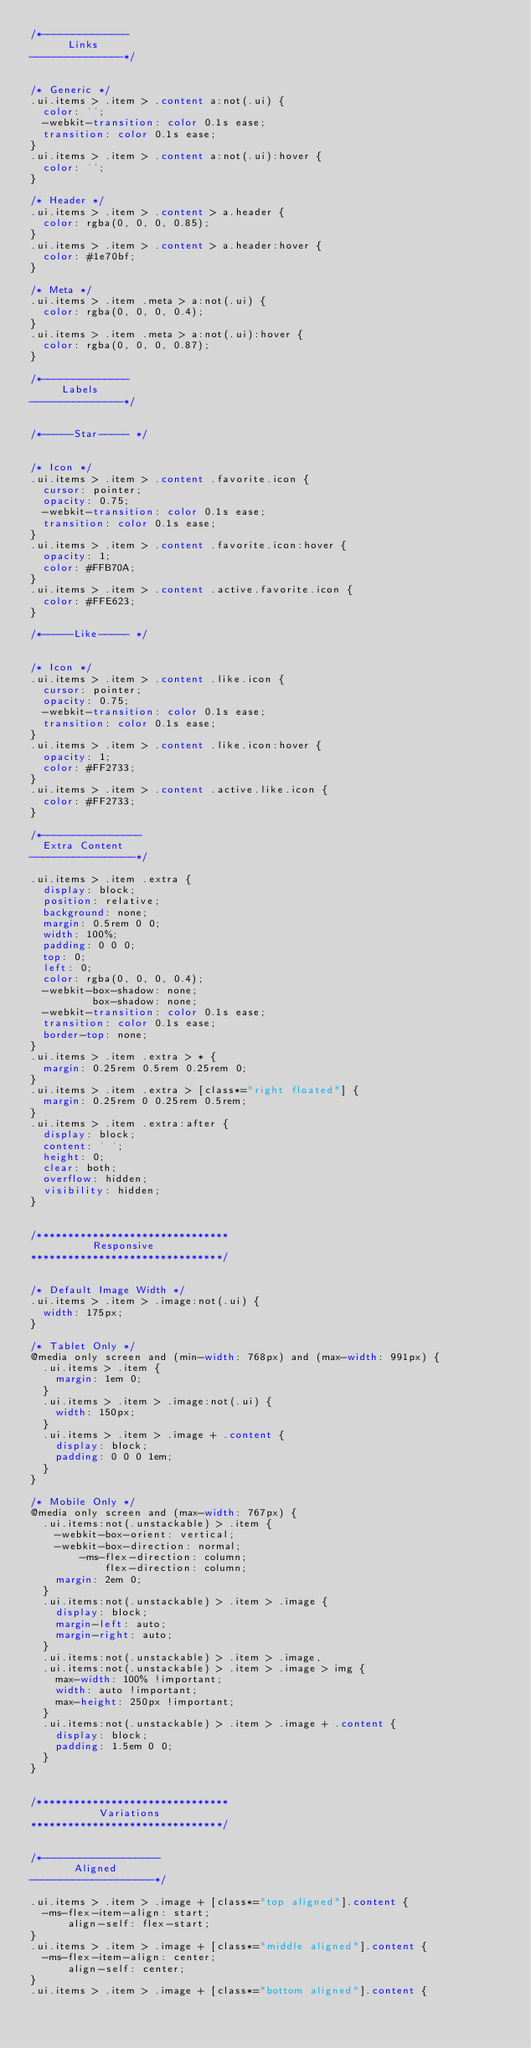Convert code to text. <code><loc_0><loc_0><loc_500><loc_500><_CSS_>/*--------------
      Links
---------------*/


/* Generic */
.ui.items > .item > .content a:not(.ui) {
  color: '';
  -webkit-transition: color 0.1s ease;
  transition: color 0.1s ease;
}
.ui.items > .item > .content a:not(.ui):hover {
  color: '';
}

/* Header */
.ui.items > .item > .content > a.header {
  color: rgba(0, 0, 0, 0.85);
}
.ui.items > .item > .content > a.header:hover {
  color: #1e70bf;
}

/* Meta */
.ui.items > .item .meta > a:not(.ui) {
  color: rgba(0, 0, 0, 0.4);
}
.ui.items > .item .meta > a:not(.ui):hover {
  color: rgba(0, 0, 0, 0.87);
}

/*--------------
     Labels
---------------*/


/*-----Star----- */


/* Icon */
.ui.items > .item > .content .favorite.icon {
  cursor: pointer;
  opacity: 0.75;
  -webkit-transition: color 0.1s ease;
  transition: color 0.1s ease;
}
.ui.items > .item > .content .favorite.icon:hover {
  opacity: 1;
  color: #FFB70A;
}
.ui.items > .item > .content .active.favorite.icon {
  color: #FFE623;
}

/*-----Like----- */


/* Icon */
.ui.items > .item > .content .like.icon {
  cursor: pointer;
  opacity: 0.75;
  -webkit-transition: color 0.1s ease;
  transition: color 0.1s ease;
}
.ui.items > .item > .content .like.icon:hover {
  opacity: 1;
  color: #FF2733;
}
.ui.items > .item > .content .active.like.icon {
  color: #FF2733;
}

/*----------------
  Extra Content
-----------------*/

.ui.items > .item .extra {
  display: block;
  position: relative;
  background: none;
  margin: 0.5rem 0 0;
  width: 100%;
  padding: 0 0 0;
  top: 0;
  left: 0;
  color: rgba(0, 0, 0, 0.4);
  -webkit-box-shadow: none;
          box-shadow: none;
  -webkit-transition: color 0.1s ease;
  transition: color 0.1s ease;
  border-top: none;
}
.ui.items > .item .extra > * {
  margin: 0.25rem 0.5rem 0.25rem 0;
}
.ui.items > .item .extra > [class*="right floated"] {
  margin: 0.25rem 0 0.25rem 0.5rem;
}
.ui.items > .item .extra:after {
  display: block;
  content: ' ';
  height: 0;
  clear: both;
  overflow: hidden;
  visibility: hidden;
}


/*******************************
          Responsive
*******************************/


/* Default Image Width */
.ui.items > .item > .image:not(.ui) {
  width: 175px;
}

/* Tablet Only */
@media only screen and (min-width: 768px) and (max-width: 991px) {
  .ui.items > .item {
    margin: 1em 0;
  }
  .ui.items > .item > .image:not(.ui) {
    width: 150px;
  }
  .ui.items > .item > .image + .content {
    display: block;
    padding: 0 0 0 1em;
  }
}

/* Mobile Only */
@media only screen and (max-width: 767px) {
  .ui.items:not(.unstackable) > .item {
    -webkit-box-orient: vertical;
    -webkit-box-direction: normal;
        -ms-flex-direction: column;
            flex-direction: column;
    margin: 2em 0;
  }
  .ui.items:not(.unstackable) > .item > .image {
    display: block;
    margin-left: auto;
    margin-right: auto;
  }
  .ui.items:not(.unstackable) > .item > .image,
  .ui.items:not(.unstackable) > .item > .image > img {
    max-width: 100% !important;
    width: auto !important;
    max-height: 250px !important;
  }
  .ui.items:not(.unstackable) > .item > .image + .content {
    display: block;
    padding: 1.5em 0 0;
  }
}


/*******************************
           Variations
*******************************/


/*-------------------
       Aligned
--------------------*/

.ui.items > .item > .image + [class*="top aligned"].content {
  -ms-flex-item-align: start;
      align-self: flex-start;
}
.ui.items > .item > .image + [class*="middle aligned"].content {
  -ms-flex-item-align: center;
      align-self: center;
}
.ui.items > .item > .image + [class*="bottom aligned"].content {</code> 